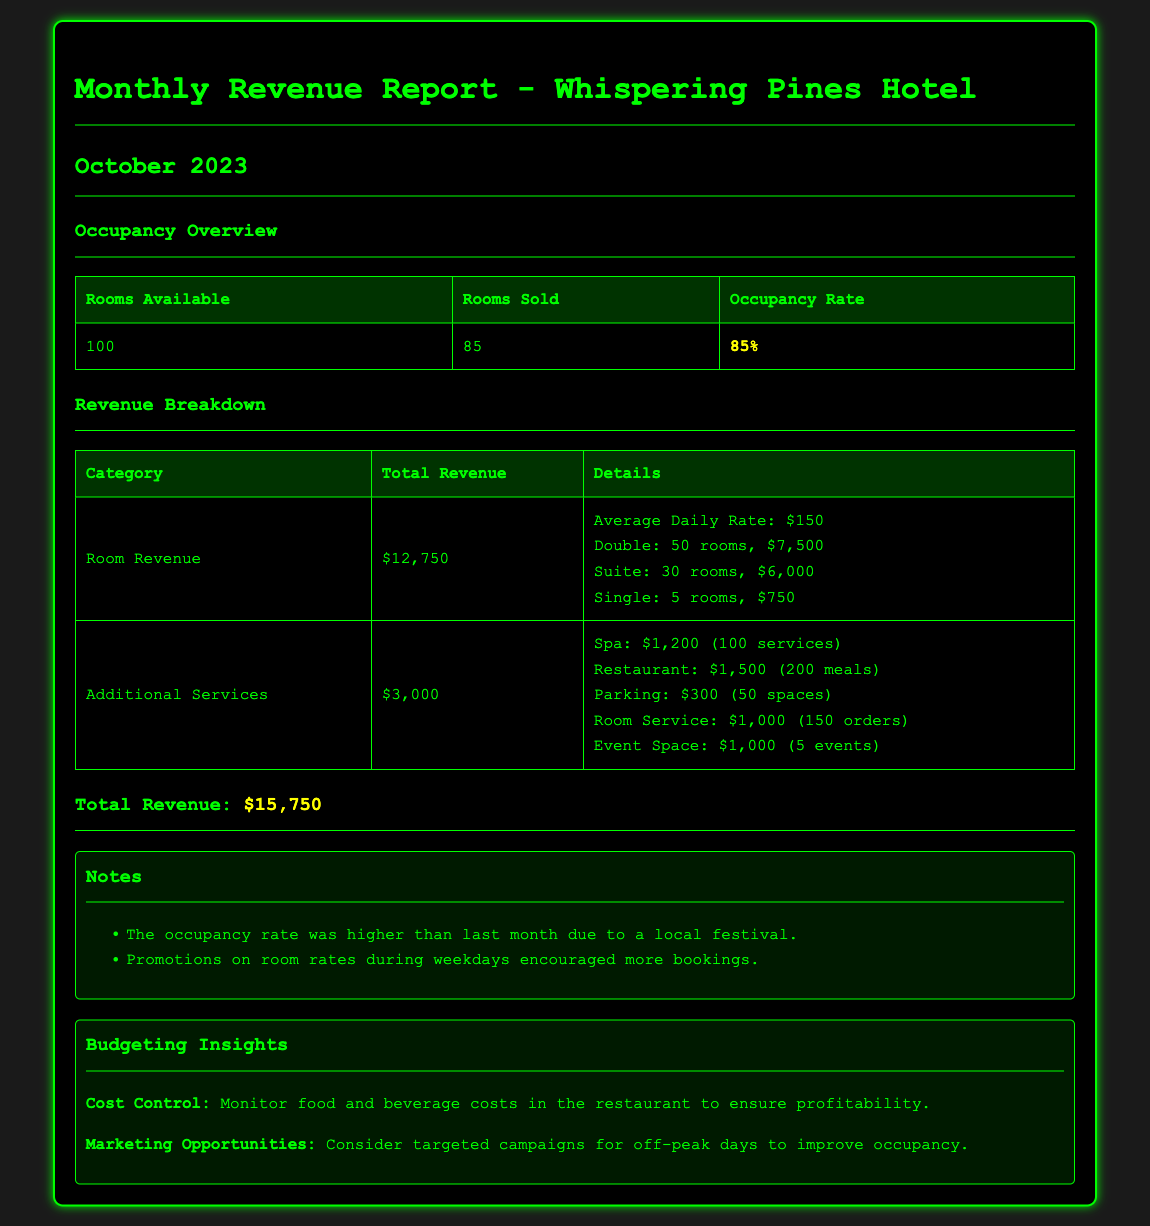What is the occupancy rate? The occupancy rate is given in the document as a percentage of rooms sold to rooms available, which is 85%.
Answer: 85% What is the total room revenue? The document specifies the total room revenue earned, which is $12,750.
Answer: $12,750 How many rooms were sold? The document states that 85 rooms were sold during the month.
Answer: 85 What was the average daily rate? The average daily rate mentioned in the document is $150.
Answer: $150 What is the revenue from the restaurant? The document lists the revenue from the restaurant as $1,500.
Answer: $1,500 What was the main contributing factor to increased occupancy? According to the notes, the occupancy rate increased due to a local festival.
Answer: local festival How many spa services were provided? The document indicates that there were 100 spa services provided.
Answer: 100 What is one area for cost control mentioned? The insights section of the document highlights the need to monitor food and beverage costs.
Answer: food and beverage costs How many events were held in the event space? The document specifies that there were 5 events in the event space.
Answer: 5 